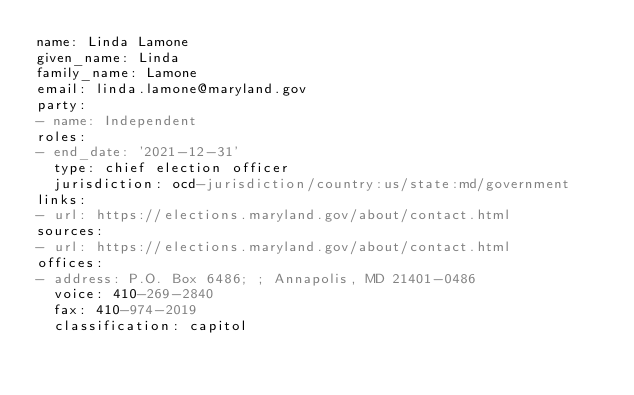<code> <loc_0><loc_0><loc_500><loc_500><_YAML_>name: Linda Lamone
given_name: Linda
family_name: Lamone
email: linda.lamone@maryland.gov
party:
- name: Independent
roles:
- end_date: '2021-12-31'
  type: chief election officer
  jurisdiction: ocd-jurisdiction/country:us/state:md/government
links:
- url: https://elections.maryland.gov/about/contact.html
sources:
- url: https://elections.maryland.gov/about/contact.html
offices:
- address: P.O. Box 6486; ; Annapolis, MD 21401-0486
  voice: 410-269-2840
  fax: 410-974-2019
  classification: capitol
</code> 